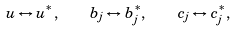<formula> <loc_0><loc_0><loc_500><loc_500>u \leftrightarrow u ^ { * } , \quad b _ { j } \leftrightarrow b ^ { * } _ { j } , \quad c _ { j } \leftrightarrow c ^ { * } _ { j } ,</formula> 